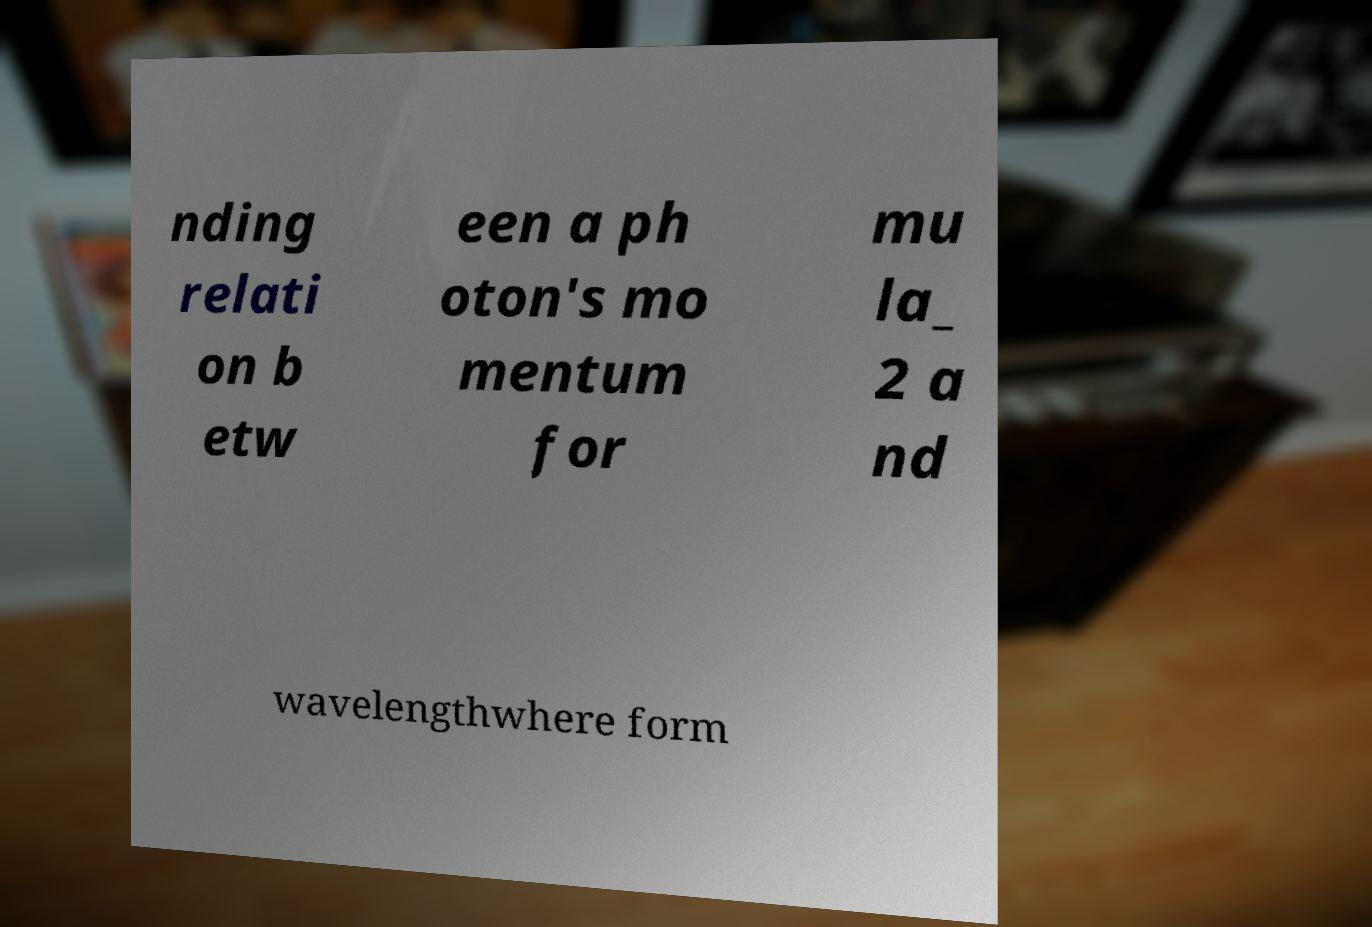Please identify and transcribe the text found in this image. nding relati on b etw een a ph oton's mo mentum for mu la_ 2 a nd wavelengthwhere form 